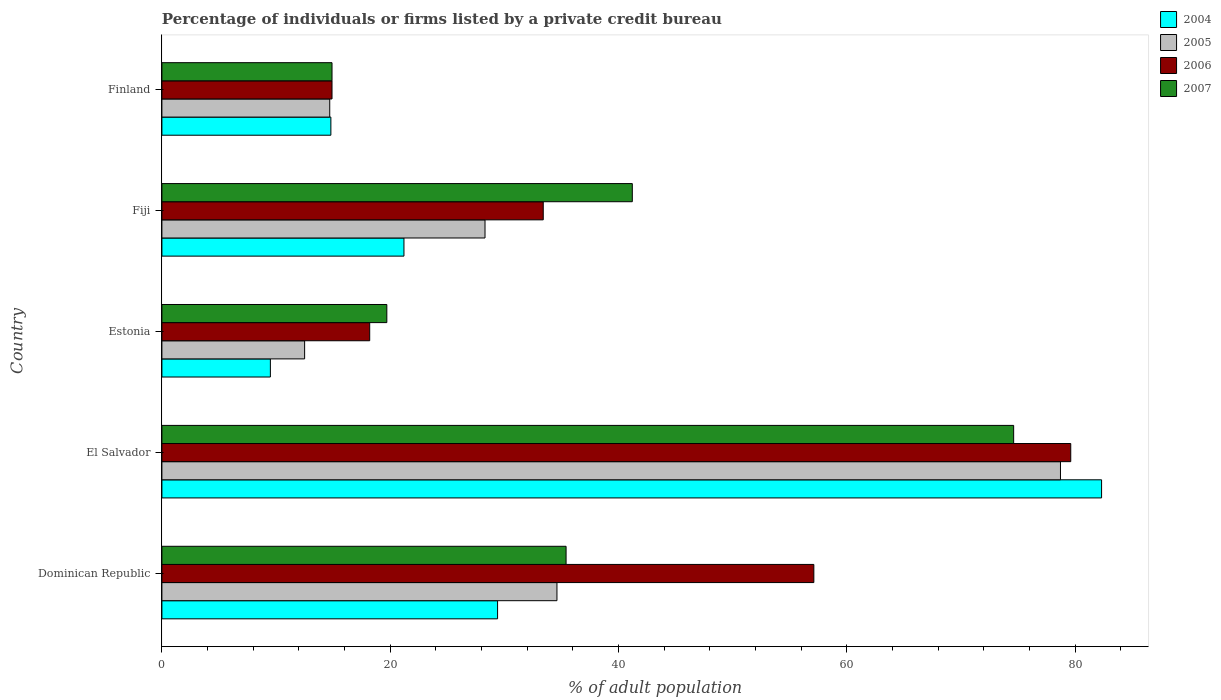How many different coloured bars are there?
Give a very brief answer. 4. Are the number of bars per tick equal to the number of legend labels?
Provide a short and direct response. Yes. How many bars are there on the 5th tick from the top?
Provide a succinct answer. 4. What is the label of the 5th group of bars from the top?
Offer a very short reply. Dominican Republic. What is the percentage of population listed by a private credit bureau in 2007 in Dominican Republic?
Your response must be concise. 35.4. Across all countries, what is the maximum percentage of population listed by a private credit bureau in 2005?
Offer a very short reply. 78.7. Across all countries, what is the minimum percentage of population listed by a private credit bureau in 2007?
Offer a terse response. 14.9. In which country was the percentage of population listed by a private credit bureau in 2004 maximum?
Offer a terse response. El Salvador. What is the total percentage of population listed by a private credit bureau in 2007 in the graph?
Your answer should be very brief. 185.8. What is the difference between the percentage of population listed by a private credit bureau in 2006 in Dominican Republic and that in El Salvador?
Your answer should be very brief. -22.5. What is the difference between the percentage of population listed by a private credit bureau in 2005 in Fiji and the percentage of population listed by a private credit bureau in 2006 in El Salvador?
Make the answer very short. -51.3. What is the average percentage of population listed by a private credit bureau in 2004 per country?
Provide a succinct answer. 31.44. What is the difference between the percentage of population listed by a private credit bureau in 2005 and percentage of population listed by a private credit bureau in 2007 in Estonia?
Make the answer very short. -7.2. What is the ratio of the percentage of population listed by a private credit bureau in 2004 in Fiji to that in Finland?
Keep it short and to the point. 1.43. Is the percentage of population listed by a private credit bureau in 2007 in Estonia less than that in Finland?
Offer a very short reply. No. What is the difference between the highest and the second highest percentage of population listed by a private credit bureau in 2007?
Your answer should be very brief. 33.4. What is the difference between the highest and the lowest percentage of population listed by a private credit bureau in 2005?
Give a very brief answer. 66.2. In how many countries, is the percentage of population listed by a private credit bureau in 2004 greater than the average percentage of population listed by a private credit bureau in 2004 taken over all countries?
Ensure brevity in your answer.  1. Is the sum of the percentage of population listed by a private credit bureau in 2005 in Estonia and Fiji greater than the maximum percentage of population listed by a private credit bureau in 2007 across all countries?
Make the answer very short. No. Is it the case that in every country, the sum of the percentage of population listed by a private credit bureau in 2006 and percentage of population listed by a private credit bureau in 2004 is greater than the sum of percentage of population listed by a private credit bureau in 2005 and percentage of population listed by a private credit bureau in 2007?
Your answer should be compact. No. What does the 1st bar from the bottom in Estonia represents?
Your answer should be very brief. 2004. Is it the case that in every country, the sum of the percentage of population listed by a private credit bureau in 2004 and percentage of population listed by a private credit bureau in 2006 is greater than the percentage of population listed by a private credit bureau in 2005?
Keep it short and to the point. Yes. How many bars are there?
Your answer should be very brief. 20. Are the values on the major ticks of X-axis written in scientific E-notation?
Ensure brevity in your answer.  No. Does the graph contain any zero values?
Offer a terse response. No. Where does the legend appear in the graph?
Offer a terse response. Top right. How many legend labels are there?
Make the answer very short. 4. How are the legend labels stacked?
Provide a short and direct response. Vertical. What is the title of the graph?
Ensure brevity in your answer.  Percentage of individuals or firms listed by a private credit bureau. What is the label or title of the X-axis?
Give a very brief answer. % of adult population. What is the % of adult population in 2004 in Dominican Republic?
Ensure brevity in your answer.  29.4. What is the % of adult population of 2005 in Dominican Republic?
Your answer should be very brief. 34.6. What is the % of adult population in 2006 in Dominican Republic?
Keep it short and to the point. 57.1. What is the % of adult population in 2007 in Dominican Republic?
Offer a terse response. 35.4. What is the % of adult population in 2004 in El Salvador?
Your response must be concise. 82.3. What is the % of adult population of 2005 in El Salvador?
Provide a succinct answer. 78.7. What is the % of adult population in 2006 in El Salvador?
Ensure brevity in your answer.  79.6. What is the % of adult population of 2007 in El Salvador?
Ensure brevity in your answer.  74.6. What is the % of adult population in 2004 in Estonia?
Provide a short and direct response. 9.5. What is the % of adult population of 2005 in Estonia?
Your answer should be compact. 12.5. What is the % of adult population in 2004 in Fiji?
Keep it short and to the point. 21.2. What is the % of adult population in 2005 in Fiji?
Your answer should be very brief. 28.3. What is the % of adult population of 2006 in Fiji?
Your response must be concise. 33.4. What is the % of adult population of 2007 in Fiji?
Your response must be concise. 41.2. What is the % of adult population of 2004 in Finland?
Provide a succinct answer. 14.8. What is the % of adult population of 2006 in Finland?
Give a very brief answer. 14.9. Across all countries, what is the maximum % of adult population in 2004?
Your answer should be compact. 82.3. Across all countries, what is the maximum % of adult population of 2005?
Provide a succinct answer. 78.7. Across all countries, what is the maximum % of adult population of 2006?
Your response must be concise. 79.6. Across all countries, what is the maximum % of adult population in 2007?
Give a very brief answer. 74.6. Across all countries, what is the minimum % of adult population of 2004?
Your answer should be very brief. 9.5. Across all countries, what is the minimum % of adult population in 2007?
Ensure brevity in your answer.  14.9. What is the total % of adult population in 2004 in the graph?
Your answer should be compact. 157.2. What is the total % of adult population of 2005 in the graph?
Provide a succinct answer. 168.8. What is the total % of adult population in 2006 in the graph?
Your response must be concise. 203.2. What is the total % of adult population of 2007 in the graph?
Offer a very short reply. 185.8. What is the difference between the % of adult population of 2004 in Dominican Republic and that in El Salvador?
Your response must be concise. -52.9. What is the difference between the % of adult population of 2005 in Dominican Republic and that in El Salvador?
Your answer should be compact. -44.1. What is the difference between the % of adult population of 2006 in Dominican Republic and that in El Salvador?
Offer a terse response. -22.5. What is the difference between the % of adult population in 2007 in Dominican Republic and that in El Salvador?
Ensure brevity in your answer.  -39.2. What is the difference between the % of adult population in 2004 in Dominican Republic and that in Estonia?
Offer a terse response. 19.9. What is the difference between the % of adult population in 2005 in Dominican Republic and that in Estonia?
Your answer should be very brief. 22.1. What is the difference between the % of adult population of 2006 in Dominican Republic and that in Estonia?
Make the answer very short. 38.9. What is the difference between the % of adult population of 2007 in Dominican Republic and that in Estonia?
Offer a terse response. 15.7. What is the difference between the % of adult population in 2005 in Dominican Republic and that in Fiji?
Provide a short and direct response. 6.3. What is the difference between the % of adult population in 2006 in Dominican Republic and that in Fiji?
Keep it short and to the point. 23.7. What is the difference between the % of adult population in 2007 in Dominican Republic and that in Fiji?
Ensure brevity in your answer.  -5.8. What is the difference between the % of adult population of 2005 in Dominican Republic and that in Finland?
Offer a very short reply. 19.9. What is the difference between the % of adult population of 2006 in Dominican Republic and that in Finland?
Offer a terse response. 42.2. What is the difference between the % of adult population in 2007 in Dominican Republic and that in Finland?
Keep it short and to the point. 20.5. What is the difference between the % of adult population in 2004 in El Salvador and that in Estonia?
Your answer should be compact. 72.8. What is the difference between the % of adult population of 2005 in El Salvador and that in Estonia?
Offer a very short reply. 66.2. What is the difference between the % of adult population of 2006 in El Salvador and that in Estonia?
Make the answer very short. 61.4. What is the difference between the % of adult population of 2007 in El Salvador and that in Estonia?
Your response must be concise. 54.9. What is the difference between the % of adult population in 2004 in El Salvador and that in Fiji?
Your response must be concise. 61.1. What is the difference between the % of adult population of 2005 in El Salvador and that in Fiji?
Ensure brevity in your answer.  50.4. What is the difference between the % of adult population in 2006 in El Salvador and that in Fiji?
Provide a short and direct response. 46.2. What is the difference between the % of adult population in 2007 in El Salvador and that in Fiji?
Give a very brief answer. 33.4. What is the difference between the % of adult population of 2004 in El Salvador and that in Finland?
Make the answer very short. 67.5. What is the difference between the % of adult population of 2006 in El Salvador and that in Finland?
Ensure brevity in your answer.  64.7. What is the difference between the % of adult population in 2007 in El Salvador and that in Finland?
Your answer should be compact. 59.7. What is the difference between the % of adult population in 2005 in Estonia and that in Fiji?
Offer a very short reply. -15.8. What is the difference between the % of adult population in 2006 in Estonia and that in Fiji?
Ensure brevity in your answer.  -15.2. What is the difference between the % of adult population of 2007 in Estonia and that in Fiji?
Offer a terse response. -21.5. What is the difference between the % of adult population in 2004 in Estonia and that in Finland?
Make the answer very short. -5.3. What is the difference between the % of adult population of 2005 in Estonia and that in Finland?
Offer a very short reply. -2.2. What is the difference between the % of adult population in 2006 in Estonia and that in Finland?
Ensure brevity in your answer.  3.3. What is the difference between the % of adult population in 2007 in Estonia and that in Finland?
Give a very brief answer. 4.8. What is the difference between the % of adult population in 2004 in Fiji and that in Finland?
Give a very brief answer. 6.4. What is the difference between the % of adult population in 2007 in Fiji and that in Finland?
Your answer should be compact. 26.3. What is the difference between the % of adult population of 2004 in Dominican Republic and the % of adult population of 2005 in El Salvador?
Keep it short and to the point. -49.3. What is the difference between the % of adult population of 2004 in Dominican Republic and the % of adult population of 2006 in El Salvador?
Keep it short and to the point. -50.2. What is the difference between the % of adult population of 2004 in Dominican Republic and the % of adult population of 2007 in El Salvador?
Your response must be concise. -45.2. What is the difference between the % of adult population in 2005 in Dominican Republic and the % of adult population in 2006 in El Salvador?
Provide a short and direct response. -45. What is the difference between the % of adult population in 2005 in Dominican Republic and the % of adult population in 2007 in El Salvador?
Your answer should be compact. -40. What is the difference between the % of adult population of 2006 in Dominican Republic and the % of adult population of 2007 in El Salvador?
Offer a very short reply. -17.5. What is the difference between the % of adult population of 2004 in Dominican Republic and the % of adult population of 2007 in Estonia?
Your answer should be compact. 9.7. What is the difference between the % of adult population in 2005 in Dominican Republic and the % of adult population in 2007 in Estonia?
Give a very brief answer. 14.9. What is the difference between the % of adult population of 2006 in Dominican Republic and the % of adult population of 2007 in Estonia?
Ensure brevity in your answer.  37.4. What is the difference between the % of adult population of 2004 in Dominican Republic and the % of adult population of 2005 in Fiji?
Offer a terse response. 1.1. What is the difference between the % of adult population in 2004 in Dominican Republic and the % of adult population in 2007 in Fiji?
Keep it short and to the point. -11.8. What is the difference between the % of adult population in 2004 in Dominican Republic and the % of adult population in 2005 in Finland?
Provide a succinct answer. 14.7. What is the difference between the % of adult population in 2005 in Dominican Republic and the % of adult population in 2006 in Finland?
Give a very brief answer. 19.7. What is the difference between the % of adult population in 2005 in Dominican Republic and the % of adult population in 2007 in Finland?
Ensure brevity in your answer.  19.7. What is the difference between the % of adult population of 2006 in Dominican Republic and the % of adult population of 2007 in Finland?
Offer a very short reply. 42.2. What is the difference between the % of adult population in 2004 in El Salvador and the % of adult population in 2005 in Estonia?
Your answer should be very brief. 69.8. What is the difference between the % of adult population in 2004 in El Salvador and the % of adult population in 2006 in Estonia?
Give a very brief answer. 64.1. What is the difference between the % of adult population in 2004 in El Salvador and the % of adult population in 2007 in Estonia?
Offer a terse response. 62.6. What is the difference between the % of adult population in 2005 in El Salvador and the % of adult population in 2006 in Estonia?
Your answer should be very brief. 60.5. What is the difference between the % of adult population in 2005 in El Salvador and the % of adult population in 2007 in Estonia?
Offer a terse response. 59. What is the difference between the % of adult population in 2006 in El Salvador and the % of adult population in 2007 in Estonia?
Your response must be concise. 59.9. What is the difference between the % of adult population of 2004 in El Salvador and the % of adult population of 2005 in Fiji?
Offer a very short reply. 54. What is the difference between the % of adult population of 2004 in El Salvador and the % of adult population of 2006 in Fiji?
Keep it short and to the point. 48.9. What is the difference between the % of adult population in 2004 in El Salvador and the % of adult population in 2007 in Fiji?
Your answer should be compact. 41.1. What is the difference between the % of adult population in 2005 in El Salvador and the % of adult population in 2006 in Fiji?
Provide a succinct answer. 45.3. What is the difference between the % of adult population of 2005 in El Salvador and the % of adult population of 2007 in Fiji?
Offer a very short reply. 37.5. What is the difference between the % of adult population in 2006 in El Salvador and the % of adult population in 2007 in Fiji?
Ensure brevity in your answer.  38.4. What is the difference between the % of adult population in 2004 in El Salvador and the % of adult population in 2005 in Finland?
Give a very brief answer. 67.6. What is the difference between the % of adult population in 2004 in El Salvador and the % of adult population in 2006 in Finland?
Make the answer very short. 67.4. What is the difference between the % of adult population of 2004 in El Salvador and the % of adult population of 2007 in Finland?
Provide a succinct answer. 67.4. What is the difference between the % of adult population in 2005 in El Salvador and the % of adult population in 2006 in Finland?
Ensure brevity in your answer.  63.8. What is the difference between the % of adult population in 2005 in El Salvador and the % of adult population in 2007 in Finland?
Provide a succinct answer. 63.8. What is the difference between the % of adult population in 2006 in El Salvador and the % of adult population in 2007 in Finland?
Make the answer very short. 64.7. What is the difference between the % of adult population in 2004 in Estonia and the % of adult population in 2005 in Fiji?
Your answer should be compact. -18.8. What is the difference between the % of adult population of 2004 in Estonia and the % of adult population of 2006 in Fiji?
Keep it short and to the point. -23.9. What is the difference between the % of adult population in 2004 in Estonia and the % of adult population in 2007 in Fiji?
Offer a very short reply. -31.7. What is the difference between the % of adult population of 2005 in Estonia and the % of adult population of 2006 in Fiji?
Make the answer very short. -20.9. What is the difference between the % of adult population of 2005 in Estonia and the % of adult population of 2007 in Fiji?
Ensure brevity in your answer.  -28.7. What is the difference between the % of adult population in 2004 in Estonia and the % of adult population in 2005 in Finland?
Give a very brief answer. -5.2. What is the difference between the % of adult population of 2004 in Estonia and the % of adult population of 2006 in Finland?
Your answer should be very brief. -5.4. What is the difference between the % of adult population in 2004 in Estonia and the % of adult population in 2007 in Finland?
Provide a short and direct response. -5.4. What is the difference between the % of adult population in 2005 in Estonia and the % of adult population in 2006 in Finland?
Keep it short and to the point. -2.4. What is the difference between the % of adult population of 2005 in Estonia and the % of adult population of 2007 in Finland?
Ensure brevity in your answer.  -2.4. What is the difference between the % of adult population in 2006 in Estonia and the % of adult population in 2007 in Finland?
Your answer should be compact. 3.3. What is the difference between the % of adult population in 2004 in Fiji and the % of adult population in 2005 in Finland?
Offer a very short reply. 6.5. What is the difference between the % of adult population of 2004 in Fiji and the % of adult population of 2007 in Finland?
Ensure brevity in your answer.  6.3. What is the difference between the % of adult population in 2005 in Fiji and the % of adult population in 2006 in Finland?
Ensure brevity in your answer.  13.4. What is the difference between the % of adult population of 2006 in Fiji and the % of adult population of 2007 in Finland?
Provide a succinct answer. 18.5. What is the average % of adult population in 2004 per country?
Give a very brief answer. 31.44. What is the average % of adult population in 2005 per country?
Your answer should be very brief. 33.76. What is the average % of adult population in 2006 per country?
Offer a very short reply. 40.64. What is the average % of adult population in 2007 per country?
Your answer should be compact. 37.16. What is the difference between the % of adult population in 2004 and % of adult population in 2006 in Dominican Republic?
Give a very brief answer. -27.7. What is the difference between the % of adult population in 2005 and % of adult population in 2006 in Dominican Republic?
Give a very brief answer. -22.5. What is the difference between the % of adult population of 2005 and % of adult population of 2007 in Dominican Republic?
Give a very brief answer. -0.8. What is the difference between the % of adult population of 2006 and % of adult population of 2007 in Dominican Republic?
Provide a succinct answer. 21.7. What is the difference between the % of adult population of 2004 and % of adult population of 2005 in El Salvador?
Your response must be concise. 3.6. What is the difference between the % of adult population of 2004 and % of adult population of 2006 in El Salvador?
Offer a very short reply. 2.7. What is the difference between the % of adult population in 2006 and % of adult population in 2007 in El Salvador?
Offer a terse response. 5. What is the difference between the % of adult population in 2004 and % of adult population in 2006 in Estonia?
Provide a succinct answer. -8.7. What is the difference between the % of adult population in 2005 and % of adult population in 2006 in Estonia?
Your answer should be very brief. -5.7. What is the difference between the % of adult population in 2004 and % of adult population in 2006 in Fiji?
Offer a very short reply. -12.2. What is the difference between the % of adult population in 2005 and % of adult population in 2006 in Fiji?
Provide a succinct answer. -5.1. What is the difference between the % of adult population in 2004 and % of adult population in 2007 in Finland?
Your answer should be very brief. -0.1. What is the difference between the % of adult population in 2005 and % of adult population in 2006 in Finland?
Your response must be concise. -0.2. What is the difference between the % of adult population of 2005 and % of adult population of 2007 in Finland?
Offer a very short reply. -0.2. What is the ratio of the % of adult population of 2004 in Dominican Republic to that in El Salvador?
Your answer should be very brief. 0.36. What is the ratio of the % of adult population in 2005 in Dominican Republic to that in El Salvador?
Offer a terse response. 0.44. What is the ratio of the % of adult population of 2006 in Dominican Republic to that in El Salvador?
Keep it short and to the point. 0.72. What is the ratio of the % of adult population of 2007 in Dominican Republic to that in El Salvador?
Keep it short and to the point. 0.47. What is the ratio of the % of adult population of 2004 in Dominican Republic to that in Estonia?
Offer a very short reply. 3.09. What is the ratio of the % of adult population in 2005 in Dominican Republic to that in Estonia?
Offer a terse response. 2.77. What is the ratio of the % of adult population of 2006 in Dominican Republic to that in Estonia?
Provide a succinct answer. 3.14. What is the ratio of the % of adult population in 2007 in Dominican Republic to that in Estonia?
Your answer should be compact. 1.8. What is the ratio of the % of adult population of 2004 in Dominican Republic to that in Fiji?
Ensure brevity in your answer.  1.39. What is the ratio of the % of adult population of 2005 in Dominican Republic to that in Fiji?
Make the answer very short. 1.22. What is the ratio of the % of adult population in 2006 in Dominican Republic to that in Fiji?
Make the answer very short. 1.71. What is the ratio of the % of adult population in 2007 in Dominican Republic to that in Fiji?
Offer a terse response. 0.86. What is the ratio of the % of adult population in 2004 in Dominican Republic to that in Finland?
Ensure brevity in your answer.  1.99. What is the ratio of the % of adult population of 2005 in Dominican Republic to that in Finland?
Offer a very short reply. 2.35. What is the ratio of the % of adult population of 2006 in Dominican Republic to that in Finland?
Provide a succinct answer. 3.83. What is the ratio of the % of adult population in 2007 in Dominican Republic to that in Finland?
Your response must be concise. 2.38. What is the ratio of the % of adult population of 2004 in El Salvador to that in Estonia?
Provide a short and direct response. 8.66. What is the ratio of the % of adult population in 2005 in El Salvador to that in Estonia?
Your answer should be very brief. 6.3. What is the ratio of the % of adult population in 2006 in El Salvador to that in Estonia?
Offer a terse response. 4.37. What is the ratio of the % of adult population in 2007 in El Salvador to that in Estonia?
Provide a short and direct response. 3.79. What is the ratio of the % of adult population in 2004 in El Salvador to that in Fiji?
Give a very brief answer. 3.88. What is the ratio of the % of adult population in 2005 in El Salvador to that in Fiji?
Ensure brevity in your answer.  2.78. What is the ratio of the % of adult population of 2006 in El Salvador to that in Fiji?
Your answer should be very brief. 2.38. What is the ratio of the % of adult population of 2007 in El Salvador to that in Fiji?
Provide a short and direct response. 1.81. What is the ratio of the % of adult population in 2004 in El Salvador to that in Finland?
Provide a succinct answer. 5.56. What is the ratio of the % of adult population of 2005 in El Salvador to that in Finland?
Your answer should be very brief. 5.35. What is the ratio of the % of adult population in 2006 in El Salvador to that in Finland?
Keep it short and to the point. 5.34. What is the ratio of the % of adult population in 2007 in El Salvador to that in Finland?
Keep it short and to the point. 5.01. What is the ratio of the % of adult population in 2004 in Estonia to that in Fiji?
Keep it short and to the point. 0.45. What is the ratio of the % of adult population in 2005 in Estonia to that in Fiji?
Your response must be concise. 0.44. What is the ratio of the % of adult population in 2006 in Estonia to that in Fiji?
Your response must be concise. 0.54. What is the ratio of the % of adult population of 2007 in Estonia to that in Fiji?
Provide a short and direct response. 0.48. What is the ratio of the % of adult population in 2004 in Estonia to that in Finland?
Offer a very short reply. 0.64. What is the ratio of the % of adult population in 2005 in Estonia to that in Finland?
Make the answer very short. 0.85. What is the ratio of the % of adult population in 2006 in Estonia to that in Finland?
Your answer should be compact. 1.22. What is the ratio of the % of adult population of 2007 in Estonia to that in Finland?
Your answer should be compact. 1.32. What is the ratio of the % of adult population of 2004 in Fiji to that in Finland?
Keep it short and to the point. 1.43. What is the ratio of the % of adult population of 2005 in Fiji to that in Finland?
Provide a succinct answer. 1.93. What is the ratio of the % of adult population in 2006 in Fiji to that in Finland?
Keep it short and to the point. 2.24. What is the ratio of the % of adult population of 2007 in Fiji to that in Finland?
Give a very brief answer. 2.77. What is the difference between the highest and the second highest % of adult population of 2004?
Keep it short and to the point. 52.9. What is the difference between the highest and the second highest % of adult population in 2005?
Your answer should be compact. 44.1. What is the difference between the highest and the second highest % of adult population in 2006?
Offer a very short reply. 22.5. What is the difference between the highest and the second highest % of adult population in 2007?
Give a very brief answer. 33.4. What is the difference between the highest and the lowest % of adult population in 2004?
Make the answer very short. 72.8. What is the difference between the highest and the lowest % of adult population of 2005?
Your answer should be compact. 66.2. What is the difference between the highest and the lowest % of adult population in 2006?
Offer a terse response. 64.7. What is the difference between the highest and the lowest % of adult population in 2007?
Provide a succinct answer. 59.7. 